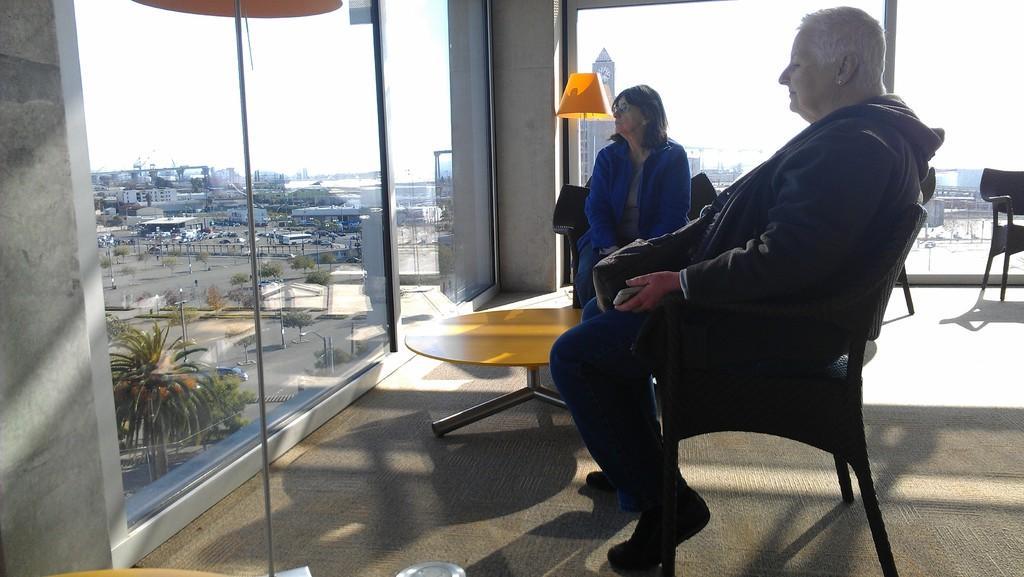Please provide a concise description of this image. In this picture we have to old woman looking at the road and there is a table in front of them also there's a lump behind them there are some buildings and there is clear sky 